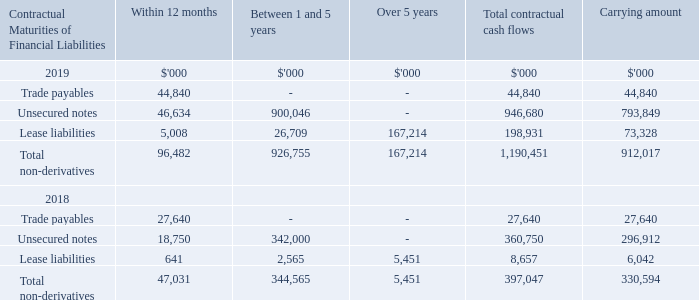15 Financial risk management (continued)
(c) Liquidity risk
Prudent liquidity risk management implies maintaining sufficient cash and marketable securities and the availability of funding through an adequate amount of committed credit facilities to meet obligations when due.
Management also actively monitors rolling forecasts of the Group’s cash and cash equivalents.
(i) Maturities of financial liabilities
The table below analyses the Group’s financial liabilities into relevant maturity groupings based on their contractual maturities for all non-derivative financial liabilities.
The amounts disclosed in the table are the contractual undiscounted cash flows.
The cash flows for unsecured notes assume that the early redemption options would not be exercised by the Group.
What were the maturity groupings of the Group's financial liabilities? Within 12 months, between 1 and 5 years, over 5 years. What was the assumption behind the cash flows for unsecured notes? The early redemption options would not be exercised by the group. What was the value of lease liabilities maturing between 1 and 5 years in 2019?
Answer scale should be: thousand. 26,709. Which financial liabilities in 2019, maturing within 12 months, was the greatest? 44,840 vs 46,634 vs 5,008
Answer: unsecured notes. What was the 2019 percentage change in carrying amount of total non-derivatives?
Answer scale should be: percent. (912,017 - 330,594) / 330,594 
Answer: 175.87. What was the 2019 percentage change in total contractual cash flows of total non-derivatives?
Answer scale should be: percent. (1,190,451 - 397,047) / 397,047 
Answer: 199.83. 